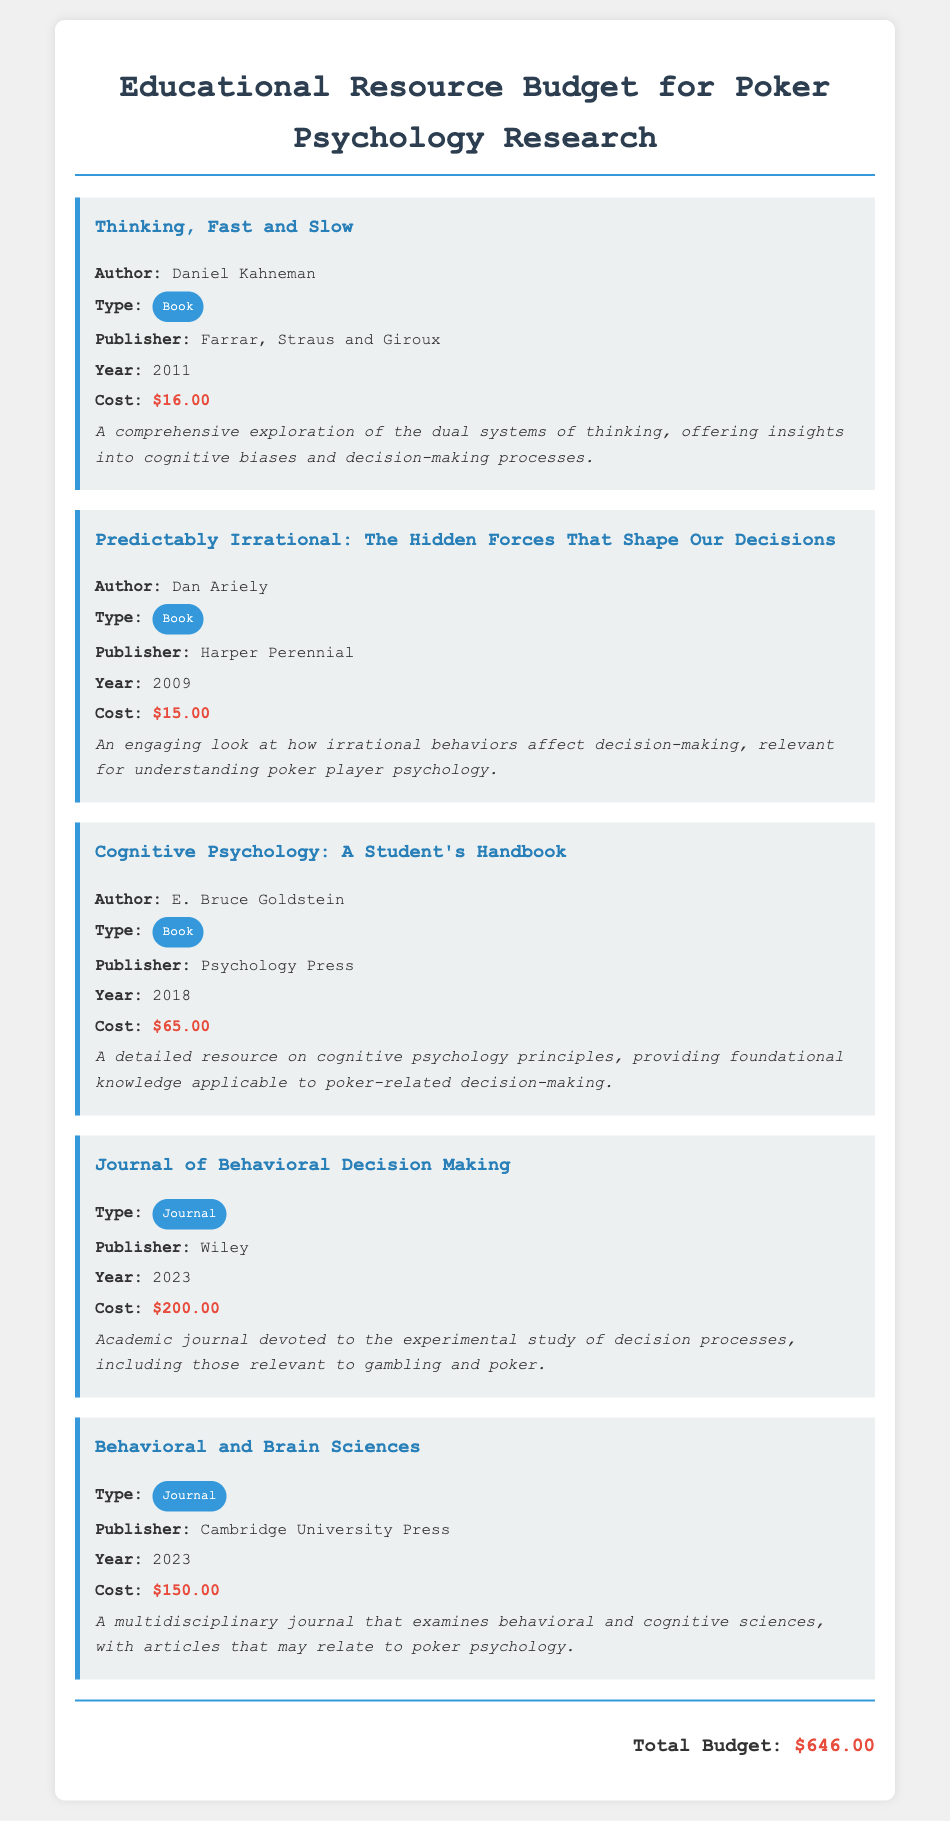What is the title of the first book listed? The title of the first book is presented in the document as the first resource, which is "Thinking, Fast and Slow."
Answer: Thinking, Fast and Slow Who is the author of "Predictably Irrational"? The author of "Predictably Irrational" is stated directly in the description of that resource as Dan Ariely.
Answer: Dan Ariely What is the cost of "Cognitive Psychology: A Student's Handbook"? The cost is explicitly mentioned alongside the book's details as $65.00.
Answer: $65.00 What is the publisher of the "Journal of Behavioral Decision Making"? The publisher of the journal is included in the journal's information as Wiley.
Answer: Wiley What year was "Thinking, Fast and Slow" published? The publication year is specified in the document as 2011.
Answer: 2011 Which type of resource is "Behavioral and Brain Sciences"? The type is indicated in the document under its title, categorizing it as a journal.
Answer: Journal What is the total budget for the educational resources? The total budget is clearly outlined at the end of the document as $646.00.
Answer: $646.00 Which book addresses cognitive biases and decision-making processes? The book providing insights into cognitive biases is introduced in the details as "Thinking, Fast and Slow."
Answer: Thinking, Fast and Slow How much does the "Journal of Behavioral Decision Making" cost? The cost is clearly noted in the journal's description as $200.00.
Answer: $200.00 